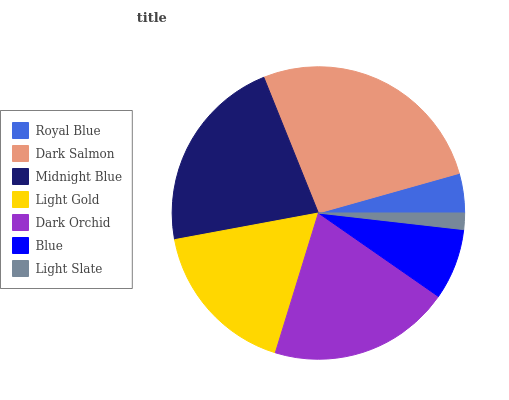Is Light Slate the minimum?
Answer yes or no. Yes. Is Dark Salmon the maximum?
Answer yes or no. Yes. Is Midnight Blue the minimum?
Answer yes or no. No. Is Midnight Blue the maximum?
Answer yes or no. No. Is Dark Salmon greater than Midnight Blue?
Answer yes or no. Yes. Is Midnight Blue less than Dark Salmon?
Answer yes or no. Yes. Is Midnight Blue greater than Dark Salmon?
Answer yes or no. No. Is Dark Salmon less than Midnight Blue?
Answer yes or no. No. Is Light Gold the high median?
Answer yes or no. Yes. Is Light Gold the low median?
Answer yes or no. Yes. Is Dark Orchid the high median?
Answer yes or no. No. Is Dark Orchid the low median?
Answer yes or no. No. 